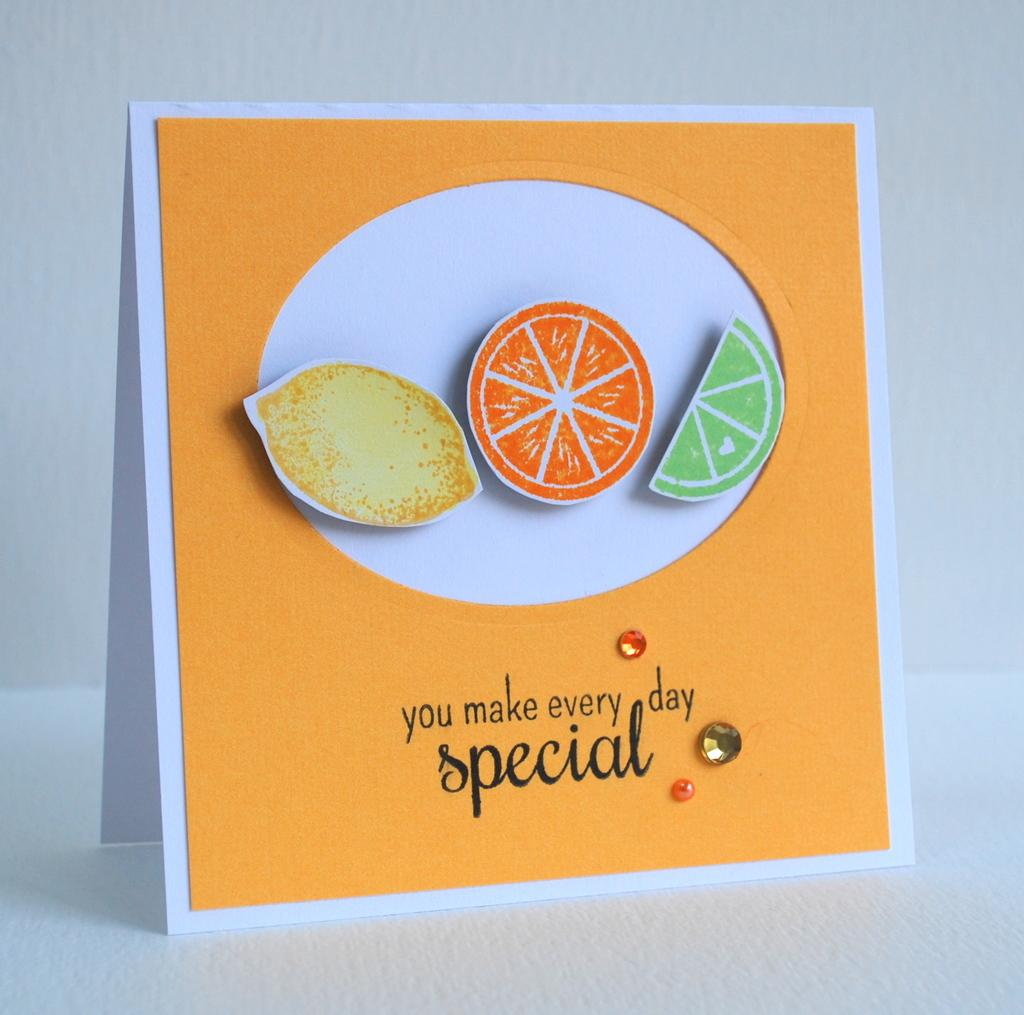What is the main object with information in the image? There is a board with information in the image. What type of craft is visible in the image? There is a paper craft in the image. What other objects can be seen in the image? There are stones in the image. On what surface is the board placed? The board is placed on a white surface. What is the color of the background in the image? The background of the image is white. What type of prose can be read on the board in the image? There is no prose present on the board in the image; it contains information. Is there a volcano visible in the image? No, there is no volcano present in the image. 